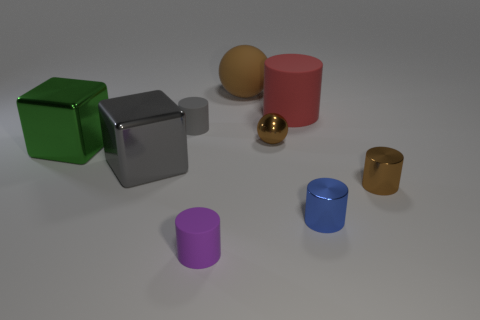Subtract all tiny purple cylinders. How many cylinders are left? 4 Subtract 1 cylinders. How many cylinders are left? 4 Subtract all cyan cylinders. Subtract all green blocks. How many cylinders are left? 5 Subtract all balls. How many objects are left? 7 Subtract 0 yellow cubes. How many objects are left? 9 Subtract all big red matte things. Subtract all large gray metallic objects. How many objects are left? 7 Add 9 large brown matte objects. How many large brown matte objects are left? 10 Add 3 yellow metal things. How many yellow metal things exist? 3 